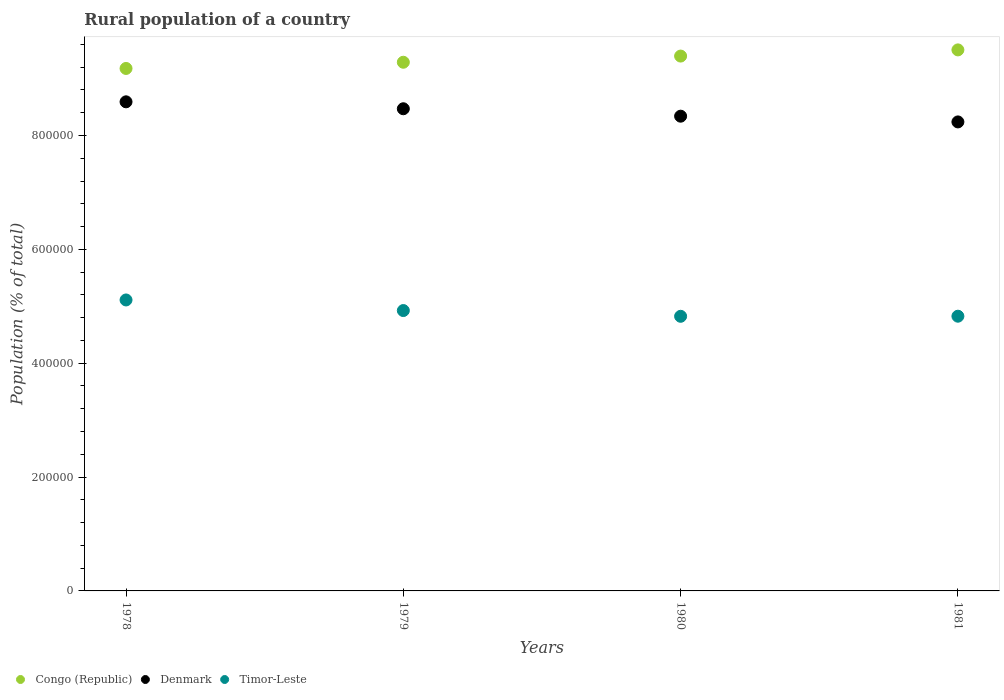How many different coloured dotlines are there?
Your answer should be very brief. 3. What is the rural population in Timor-Leste in 1978?
Offer a terse response. 5.11e+05. Across all years, what is the maximum rural population in Timor-Leste?
Your response must be concise. 5.11e+05. Across all years, what is the minimum rural population in Timor-Leste?
Make the answer very short. 4.82e+05. In which year was the rural population in Denmark maximum?
Your response must be concise. 1978. In which year was the rural population in Congo (Republic) minimum?
Give a very brief answer. 1978. What is the total rural population in Denmark in the graph?
Your response must be concise. 3.36e+06. What is the difference between the rural population in Timor-Leste in 1978 and that in 1981?
Offer a very short reply. 2.85e+04. What is the difference between the rural population in Denmark in 1979 and the rural population in Timor-Leste in 1978?
Your response must be concise. 3.36e+05. What is the average rural population in Denmark per year?
Your response must be concise. 8.41e+05. In the year 1979, what is the difference between the rural population in Timor-Leste and rural population in Denmark?
Keep it short and to the point. -3.54e+05. In how many years, is the rural population in Congo (Republic) greater than 80000 %?
Give a very brief answer. 4. What is the ratio of the rural population in Timor-Leste in 1979 to that in 1981?
Offer a terse response. 1.02. Is the difference between the rural population in Timor-Leste in 1978 and 1979 greater than the difference between the rural population in Denmark in 1978 and 1979?
Offer a terse response. Yes. What is the difference between the highest and the second highest rural population in Timor-Leste?
Ensure brevity in your answer.  1.86e+04. What is the difference between the highest and the lowest rural population in Denmark?
Provide a succinct answer. 3.53e+04. Is the sum of the rural population in Denmark in 1979 and 1980 greater than the maximum rural population in Timor-Leste across all years?
Provide a short and direct response. Yes. How many dotlines are there?
Provide a short and direct response. 3. How many years are there in the graph?
Offer a very short reply. 4. What is the difference between two consecutive major ticks on the Y-axis?
Your answer should be compact. 2.00e+05. Are the values on the major ticks of Y-axis written in scientific E-notation?
Offer a very short reply. No. Does the graph contain any zero values?
Your answer should be very brief. No. Does the graph contain grids?
Offer a very short reply. No. How are the legend labels stacked?
Make the answer very short. Horizontal. What is the title of the graph?
Your answer should be very brief. Rural population of a country. Does "Switzerland" appear as one of the legend labels in the graph?
Provide a short and direct response. No. What is the label or title of the Y-axis?
Make the answer very short. Population (% of total). What is the Population (% of total) of Congo (Republic) in 1978?
Provide a short and direct response. 9.18e+05. What is the Population (% of total) of Denmark in 1978?
Your answer should be compact. 8.59e+05. What is the Population (% of total) of Timor-Leste in 1978?
Your answer should be compact. 5.11e+05. What is the Population (% of total) in Congo (Republic) in 1979?
Give a very brief answer. 9.29e+05. What is the Population (% of total) in Denmark in 1979?
Your answer should be very brief. 8.47e+05. What is the Population (% of total) of Timor-Leste in 1979?
Give a very brief answer. 4.92e+05. What is the Population (% of total) of Congo (Republic) in 1980?
Your answer should be compact. 9.39e+05. What is the Population (% of total) of Denmark in 1980?
Give a very brief answer. 8.34e+05. What is the Population (% of total) in Timor-Leste in 1980?
Give a very brief answer. 4.82e+05. What is the Population (% of total) in Congo (Republic) in 1981?
Ensure brevity in your answer.  9.50e+05. What is the Population (% of total) of Denmark in 1981?
Your answer should be very brief. 8.24e+05. What is the Population (% of total) in Timor-Leste in 1981?
Offer a terse response. 4.83e+05. Across all years, what is the maximum Population (% of total) in Congo (Republic)?
Your answer should be compact. 9.50e+05. Across all years, what is the maximum Population (% of total) of Denmark?
Offer a terse response. 8.59e+05. Across all years, what is the maximum Population (% of total) of Timor-Leste?
Keep it short and to the point. 5.11e+05. Across all years, what is the minimum Population (% of total) in Congo (Republic)?
Keep it short and to the point. 9.18e+05. Across all years, what is the minimum Population (% of total) of Denmark?
Keep it short and to the point. 8.24e+05. Across all years, what is the minimum Population (% of total) in Timor-Leste?
Give a very brief answer. 4.82e+05. What is the total Population (% of total) in Congo (Republic) in the graph?
Provide a succinct answer. 3.74e+06. What is the total Population (% of total) in Denmark in the graph?
Give a very brief answer. 3.36e+06. What is the total Population (% of total) of Timor-Leste in the graph?
Your response must be concise. 1.97e+06. What is the difference between the Population (% of total) in Congo (Republic) in 1978 and that in 1979?
Your response must be concise. -1.09e+04. What is the difference between the Population (% of total) in Denmark in 1978 and that in 1979?
Offer a very short reply. 1.22e+04. What is the difference between the Population (% of total) of Timor-Leste in 1978 and that in 1979?
Ensure brevity in your answer.  1.86e+04. What is the difference between the Population (% of total) in Congo (Republic) in 1978 and that in 1980?
Your response must be concise. -2.17e+04. What is the difference between the Population (% of total) in Denmark in 1978 and that in 1980?
Ensure brevity in your answer.  2.52e+04. What is the difference between the Population (% of total) of Timor-Leste in 1978 and that in 1980?
Give a very brief answer. 2.87e+04. What is the difference between the Population (% of total) of Congo (Republic) in 1978 and that in 1981?
Your response must be concise. -3.26e+04. What is the difference between the Population (% of total) in Denmark in 1978 and that in 1981?
Provide a short and direct response. 3.53e+04. What is the difference between the Population (% of total) of Timor-Leste in 1978 and that in 1981?
Offer a very short reply. 2.85e+04. What is the difference between the Population (% of total) in Congo (Republic) in 1979 and that in 1980?
Give a very brief answer. -1.08e+04. What is the difference between the Population (% of total) of Denmark in 1979 and that in 1980?
Provide a succinct answer. 1.31e+04. What is the difference between the Population (% of total) of Timor-Leste in 1979 and that in 1980?
Offer a very short reply. 1.01e+04. What is the difference between the Population (% of total) in Congo (Republic) in 1979 and that in 1981?
Your answer should be compact. -2.17e+04. What is the difference between the Population (% of total) in Denmark in 1979 and that in 1981?
Offer a terse response. 2.31e+04. What is the difference between the Population (% of total) of Timor-Leste in 1979 and that in 1981?
Ensure brevity in your answer.  9921. What is the difference between the Population (% of total) in Congo (Republic) in 1980 and that in 1981?
Keep it short and to the point. -1.09e+04. What is the difference between the Population (% of total) in Denmark in 1980 and that in 1981?
Offer a terse response. 1.01e+04. What is the difference between the Population (% of total) in Timor-Leste in 1980 and that in 1981?
Keep it short and to the point. -164. What is the difference between the Population (% of total) in Congo (Republic) in 1978 and the Population (% of total) in Denmark in 1979?
Your answer should be compact. 7.08e+04. What is the difference between the Population (% of total) of Congo (Republic) in 1978 and the Population (% of total) of Timor-Leste in 1979?
Ensure brevity in your answer.  4.25e+05. What is the difference between the Population (% of total) in Denmark in 1978 and the Population (% of total) in Timor-Leste in 1979?
Make the answer very short. 3.67e+05. What is the difference between the Population (% of total) in Congo (Republic) in 1978 and the Population (% of total) in Denmark in 1980?
Provide a succinct answer. 8.38e+04. What is the difference between the Population (% of total) in Congo (Republic) in 1978 and the Population (% of total) in Timor-Leste in 1980?
Give a very brief answer. 4.35e+05. What is the difference between the Population (% of total) in Denmark in 1978 and the Population (% of total) in Timor-Leste in 1980?
Ensure brevity in your answer.  3.77e+05. What is the difference between the Population (% of total) of Congo (Republic) in 1978 and the Population (% of total) of Denmark in 1981?
Your answer should be compact. 9.39e+04. What is the difference between the Population (% of total) in Congo (Republic) in 1978 and the Population (% of total) in Timor-Leste in 1981?
Your answer should be very brief. 4.35e+05. What is the difference between the Population (% of total) of Denmark in 1978 and the Population (% of total) of Timor-Leste in 1981?
Keep it short and to the point. 3.77e+05. What is the difference between the Population (% of total) in Congo (Republic) in 1979 and the Population (% of total) in Denmark in 1980?
Make the answer very short. 9.47e+04. What is the difference between the Population (% of total) of Congo (Republic) in 1979 and the Population (% of total) of Timor-Leste in 1980?
Provide a short and direct response. 4.46e+05. What is the difference between the Population (% of total) of Denmark in 1979 and the Population (% of total) of Timor-Leste in 1980?
Keep it short and to the point. 3.65e+05. What is the difference between the Population (% of total) in Congo (Republic) in 1979 and the Population (% of total) in Denmark in 1981?
Provide a succinct answer. 1.05e+05. What is the difference between the Population (% of total) in Congo (Republic) in 1979 and the Population (% of total) in Timor-Leste in 1981?
Ensure brevity in your answer.  4.46e+05. What is the difference between the Population (% of total) in Denmark in 1979 and the Population (% of total) in Timor-Leste in 1981?
Keep it short and to the point. 3.64e+05. What is the difference between the Population (% of total) in Congo (Republic) in 1980 and the Population (% of total) in Denmark in 1981?
Offer a very short reply. 1.16e+05. What is the difference between the Population (% of total) in Congo (Republic) in 1980 and the Population (% of total) in Timor-Leste in 1981?
Your answer should be compact. 4.57e+05. What is the difference between the Population (% of total) in Denmark in 1980 and the Population (% of total) in Timor-Leste in 1981?
Make the answer very short. 3.51e+05. What is the average Population (% of total) in Congo (Republic) per year?
Offer a terse response. 9.34e+05. What is the average Population (% of total) of Denmark per year?
Make the answer very short. 8.41e+05. What is the average Population (% of total) in Timor-Leste per year?
Ensure brevity in your answer.  4.92e+05. In the year 1978, what is the difference between the Population (% of total) in Congo (Republic) and Population (% of total) in Denmark?
Keep it short and to the point. 5.86e+04. In the year 1978, what is the difference between the Population (% of total) of Congo (Republic) and Population (% of total) of Timor-Leste?
Offer a terse response. 4.07e+05. In the year 1978, what is the difference between the Population (% of total) of Denmark and Population (% of total) of Timor-Leste?
Offer a very short reply. 3.48e+05. In the year 1979, what is the difference between the Population (% of total) in Congo (Republic) and Population (% of total) in Denmark?
Offer a terse response. 8.17e+04. In the year 1979, what is the difference between the Population (% of total) of Congo (Republic) and Population (% of total) of Timor-Leste?
Your answer should be very brief. 4.36e+05. In the year 1979, what is the difference between the Population (% of total) in Denmark and Population (% of total) in Timor-Leste?
Ensure brevity in your answer.  3.54e+05. In the year 1980, what is the difference between the Population (% of total) of Congo (Republic) and Population (% of total) of Denmark?
Keep it short and to the point. 1.06e+05. In the year 1980, what is the difference between the Population (% of total) of Congo (Republic) and Population (% of total) of Timor-Leste?
Your answer should be very brief. 4.57e+05. In the year 1980, what is the difference between the Population (% of total) in Denmark and Population (% of total) in Timor-Leste?
Offer a terse response. 3.51e+05. In the year 1981, what is the difference between the Population (% of total) in Congo (Republic) and Population (% of total) in Denmark?
Give a very brief answer. 1.27e+05. In the year 1981, what is the difference between the Population (% of total) of Congo (Republic) and Population (% of total) of Timor-Leste?
Give a very brief answer. 4.68e+05. In the year 1981, what is the difference between the Population (% of total) of Denmark and Population (% of total) of Timor-Leste?
Keep it short and to the point. 3.41e+05. What is the ratio of the Population (% of total) of Congo (Republic) in 1978 to that in 1979?
Keep it short and to the point. 0.99. What is the ratio of the Population (% of total) of Denmark in 1978 to that in 1979?
Make the answer very short. 1.01. What is the ratio of the Population (% of total) of Timor-Leste in 1978 to that in 1979?
Make the answer very short. 1.04. What is the ratio of the Population (% of total) of Congo (Republic) in 1978 to that in 1980?
Provide a short and direct response. 0.98. What is the ratio of the Population (% of total) in Denmark in 1978 to that in 1980?
Ensure brevity in your answer.  1.03. What is the ratio of the Population (% of total) in Timor-Leste in 1978 to that in 1980?
Your answer should be compact. 1.06. What is the ratio of the Population (% of total) of Congo (Republic) in 1978 to that in 1981?
Give a very brief answer. 0.97. What is the ratio of the Population (% of total) of Denmark in 1978 to that in 1981?
Your answer should be compact. 1.04. What is the ratio of the Population (% of total) in Timor-Leste in 1978 to that in 1981?
Ensure brevity in your answer.  1.06. What is the ratio of the Population (% of total) in Denmark in 1979 to that in 1980?
Offer a very short reply. 1.02. What is the ratio of the Population (% of total) of Timor-Leste in 1979 to that in 1980?
Offer a very short reply. 1.02. What is the ratio of the Population (% of total) in Congo (Republic) in 1979 to that in 1981?
Offer a terse response. 0.98. What is the ratio of the Population (% of total) of Denmark in 1979 to that in 1981?
Offer a terse response. 1.03. What is the ratio of the Population (% of total) in Timor-Leste in 1979 to that in 1981?
Make the answer very short. 1.02. What is the ratio of the Population (% of total) in Congo (Republic) in 1980 to that in 1981?
Your answer should be compact. 0.99. What is the ratio of the Population (% of total) in Denmark in 1980 to that in 1981?
Give a very brief answer. 1.01. What is the ratio of the Population (% of total) of Timor-Leste in 1980 to that in 1981?
Ensure brevity in your answer.  1. What is the difference between the highest and the second highest Population (% of total) of Congo (Republic)?
Offer a terse response. 1.09e+04. What is the difference between the highest and the second highest Population (% of total) in Denmark?
Make the answer very short. 1.22e+04. What is the difference between the highest and the second highest Population (% of total) in Timor-Leste?
Offer a very short reply. 1.86e+04. What is the difference between the highest and the lowest Population (% of total) of Congo (Republic)?
Your response must be concise. 3.26e+04. What is the difference between the highest and the lowest Population (% of total) of Denmark?
Your response must be concise. 3.53e+04. What is the difference between the highest and the lowest Population (% of total) in Timor-Leste?
Make the answer very short. 2.87e+04. 